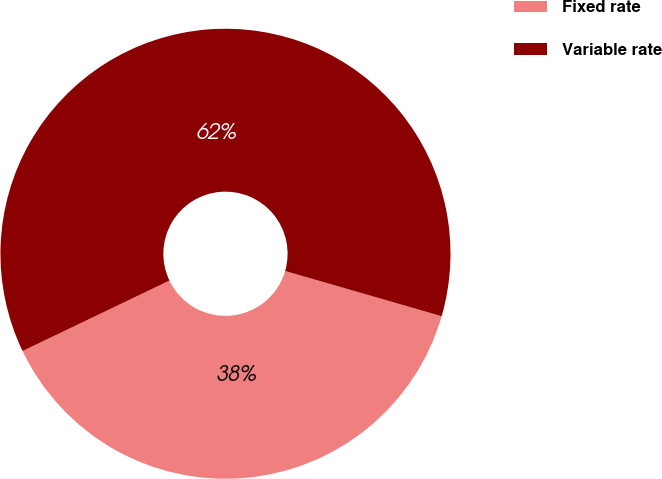Convert chart. <chart><loc_0><loc_0><loc_500><loc_500><pie_chart><fcel>Fixed rate<fcel>Variable rate<nl><fcel>38.41%<fcel>61.59%<nl></chart> 